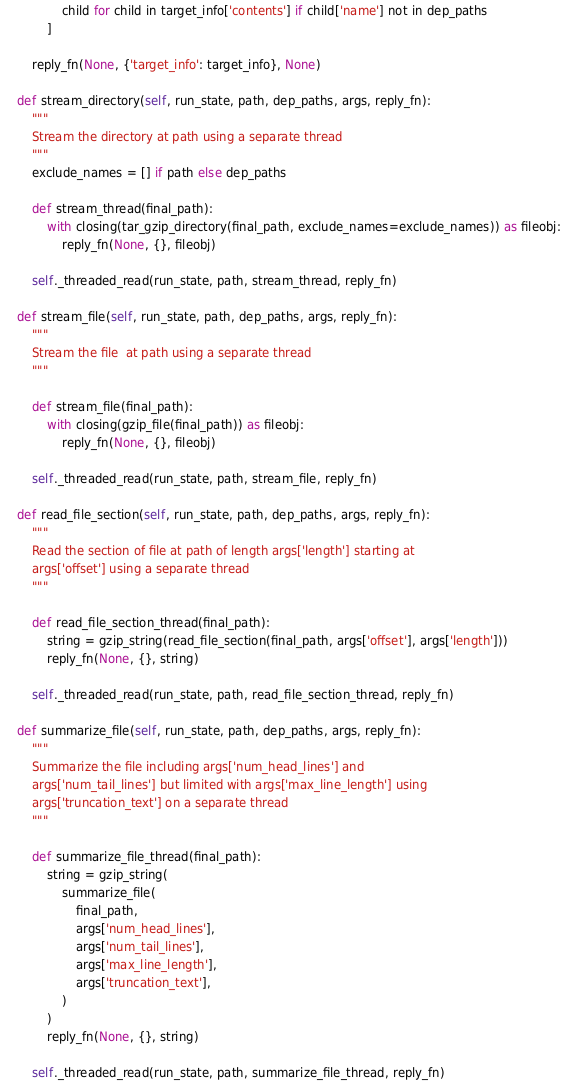Convert code to text. <code><loc_0><loc_0><loc_500><loc_500><_Python_>                child for child in target_info['contents'] if child['name'] not in dep_paths
            ]

        reply_fn(None, {'target_info': target_info}, None)

    def stream_directory(self, run_state, path, dep_paths, args, reply_fn):
        """
        Stream the directory at path using a separate thread
        """
        exclude_names = [] if path else dep_paths

        def stream_thread(final_path):
            with closing(tar_gzip_directory(final_path, exclude_names=exclude_names)) as fileobj:
                reply_fn(None, {}, fileobj)

        self._threaded_read(run_state, path, stream_thread, reply_fn)

    def stream_file(self, run_state, path, dep_paths, args, reply_fn):
        """
        Stream the file  at path using a separate thread
        """

        def stream_file(final_path):
            with closing(gzip_file(final_path)) as fileobj:
                reply_fn(None, {}, fileobj)

        self._threaded_read(run_state, path, stream_file, reply_fn)

    def read_file_section(self, run_state, path, dep_paths, args, reply_fn):
        """
        Read the section of file at path of length args['length'] starting at
        args['offset'] using a separate thread
        """

        def read_file_section_thread(final_path):
            string = gzip_string(read_file_section(final_path, args['offset'], args['length']))
            reply_fn(None, {}, string)

        self._threaded_read(run_state, path, read_file_section_thread, reply_fn)

    def summarize_file(self, run_state, path, dep_paths, args, reply_fn):
        """
        Summarize the file including args['num_head_lines'] and
        args['num_tail_lines'] but limited with args['max_line_length'] using
        args['truncation_text'] on a separate thread
        """

        def summarize_file_thread(final_path):
            string = gzip_string(
                summarize_file(
                    final_path,
                    args['num_head_lines'],
                    args['num_tail_lines'],
                    args['max_line_length'],
                    args['truncation_text'],
                )
            )
            reply_fn(None, {}, string)

        self._threaded_read(run_state, path, summarize_file_thread, reply_fn)
</code> 